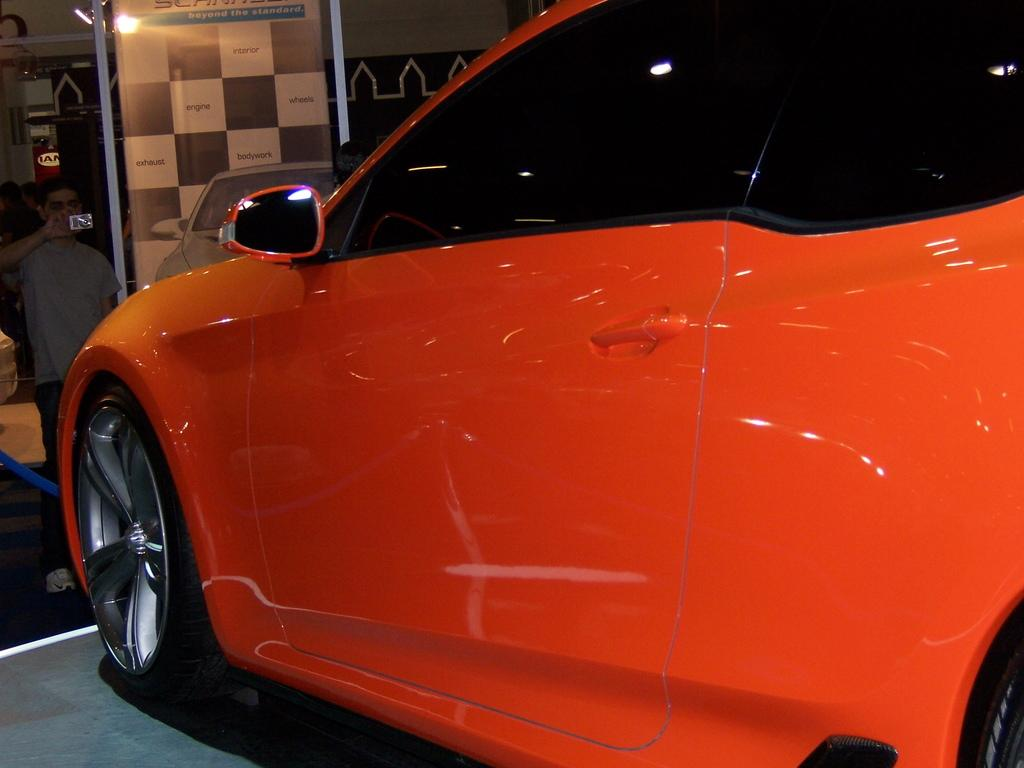What is the main subject in the center of the image? There is a car in the center of the image. Can you describe the person in the background? The person in the background is standing and holding a mobile. What can be seen in the background besides the person? There is a light, a banner, a wall, and other objects present in the background. What type of jam is the person spreading on the car in the image? There is no jam present in the image, nor is there any indication that the person is spreading jam on the car. 